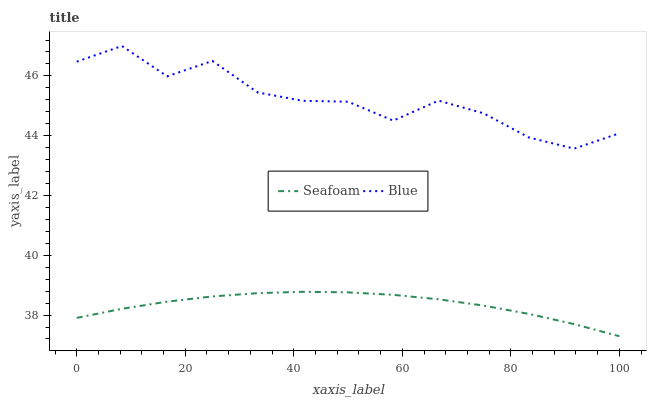Does Seafoam have the minimum area under the curve?
Answer yes or no. Yes. Does Blue have the maximum area under the curve?
Answer yes or no. Yes. Does Seafoam have the maximum area under the curve?
Answer yes or no. No. Is Seafoam the smoothest?
Answer yes or no. Yes. Is Blue the roughest?
Answer yes or no. Yes. Is Seafoam the roughest?
Answer yes or no. No. Does Seafoam have the lowest value?
Answer yes or no. Yes. Does Blue have the highest value?
Answer yes or no. Yes. Does Seafoam have the highest value?
Answer yes or no. No. Is Seafoam less than Blue?
Answer yes or no. Yes. Is Blue greater than Seafoam?
Answer yes or no. Yes. Does Seafoam intersect Blue?
Answer yes or no. No. 